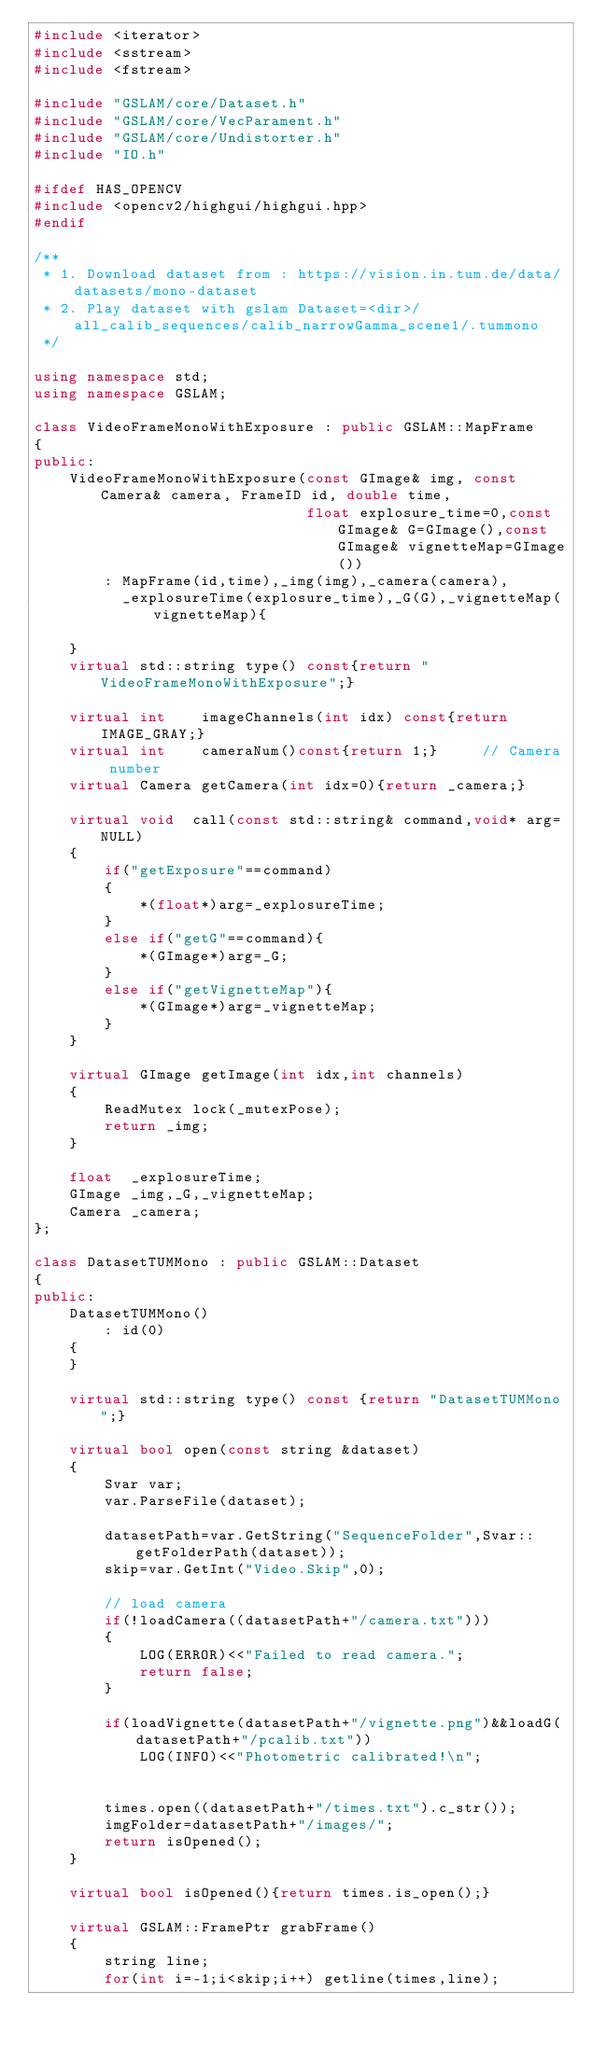Convert code to text. <code><loc_0><loc_0><loc_500><loc_500><_C++_>#include <iterator>
#include <sstream>
#include <fstream>

#include "GSLAM/core/Dataset.h"
#include "GSLAM/core/VecParament.h"
#include "GSLAM/core/Undistorter.h"
#include "IO.h"

#ifdef HAS_OPENCV
#include <opencv2/highgui/highgui.hpp>
#endif

/**
 * 1. Download dataset from : https://vision.in.tum.de/data/datasets/mono-dataset
 * 2. Play dataset with gslam Dataset=<dir>/all_calib_sequences/calib_narrowGamma_scene1/.tummono
 */

using namespace std;
using namespace GSLAM;

class VideoFrameMonoWithExposure : public GSLAM::MapFrame
{
public:
    VideoFrameMonoWithExposure(const GImage& img, const Camera& camera, FrameID id, double time,
                               float explosure_time=0,const GImage& G=GImage(),const GImage& vignetteMap=GImage())
        : MapFrame(id,time),_img(img),_camera(camera),
          _explosureTime(explosure_time),_G(G),_vignetteMap(vignetteMap){

    }
    virtual std::string type() const{return "VideoFrameMonoWithExposure";}

    virtual int    imageChannels(int idx) const{return IMAGE_GRAY;}
    virtual int    cameraNum()const{return 1;}     // Camera number
    virtual Camera getCamera(int idx=0){return _camera;}

    virtual void  call(const std::string& command,void* arg=NULL)
    {
        if("getExposure"==command)
        {
            *(float*)arg=_explosureTime;
        }
        else if("getG"==command){
            *(GImage*)arg=_G;
        }
        else if("getVignetteMap"){
            *(GImage*)arg=_vignetteMap;
        }
    }

    virtual GImage getImage(int idx,int channels)
    {
        ReadMutex lock(_mutexPose);
        return _img;
    }

    float  _explosureTime;
    GImage _img,_G,_vignetteMap;
    Camera _camera;
};

class DatasetTUMMono : public GSLAM::Dataset
{
public:
    DatasetTUMMono()
        : id(0)
    {        
    }

    virtual std::string type() const {return "DatasetTUMMono";}

    virtual bool open(const string &dataset)
    {
        Svar var;
        var.ParseFile(dataset);

        datasetPath=var.GetString("SequenceFolder",Svar::getFolderPath(dataset));
        skip=var.GetInt("Video.Skip",0);

        // load camera
        if(!loadCamera((datasetPath+"/camera.txt")))
        {
            LOG(ERROR)<<"Failed to read camera.";
            return false;
        }

        if(loadVignette(datasetPath+"/vignette.png")&&loadG(datasetPath+"/pcalib.txt"))
            LOG(INFO)<<"Photometric calibrated!\n";


        times.open((datasetPath+"/times.txt").c_str());
        imgFolder=datasetPath+"/images/";
        return isOpened();
    }

    virtual bool isOpened(){return times.is_open();}

    virtual GSLAM::FramePtr grabFrame()
    {
        string line;
        for(int i=-1;i<skip;i++) getline(times,line);</code> 